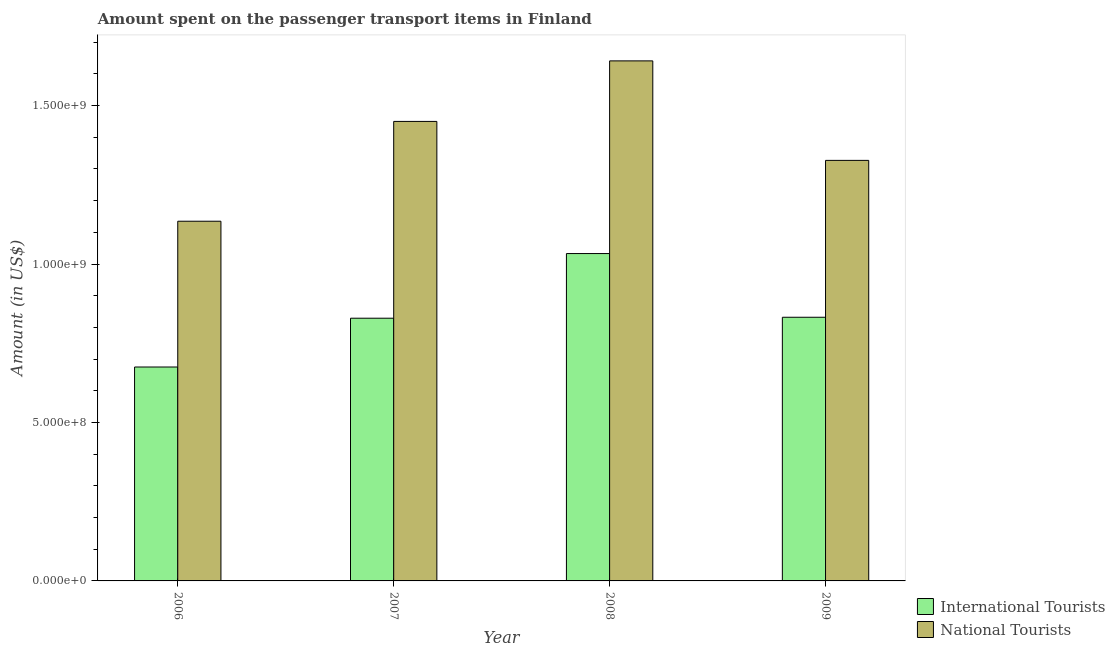How many different coloured bars are there?
Provide a short and direct response. 2. How many groups of bars are there?
Your response must be concise. 4. How many bars are there on the 4th tick from the left?
Offer a very short reply. 2. How many bars are there on the 4th tick from the right?
Provide a short and direct response. 2. In how many cases, is the number of bars for a given year not equal to the number of legend labels?
Give a very brief answer. 0. What is the amount spent on transport items of national tourists in 2008?
Offer a very short reply. 1.64e+09. Across all years, what is the maximum amount spent on transport items of national tourists?
Provide a short and direct response. 1.64e+09. Across all years, what is the minimum amount spent on transport items of international tourists?
Your response must be concise. 6.75e+08. In which year was the amount spent on transport items of national tourists maximum?
Offer a very short reply. 2008. In which year was the amount spent on transport items of national tourists minimum?
Provide a short and direct response. 2006. What is the total amount spent on transport items of national tourists in the graph?
Give a very brief answer. 5.55e+09. What is the difference between the amount spent on transport items of international tourists in 2006 and that in 2009?
Your response must be concise. -1.57e+08. What is the difference between the amount spent on transport items of national tourists in 2006 and the amount spent on transport items of international tourists in 2008?
Offer a terse response. -5.06e+08. What is the average amount spent on transport items of national tourists per year?
Offer a very short reply. 1.39e+09. In the year 2008, what is the difference between the amount spent on transport items of national tourists and amount spent on transport items of international tourists?
Ensure brevity in your answer.  0. In how many years, is the amount spent on transport items of national tourists greater than 1200000000 US$?
Provide a succinct answer. 3. What is the ratio of the amount spent on transport items of international tourists in 2008 to that in 2009?
Offer a very short reply. 1.24. Is the amount spent on transport items of international tourists in 2006 less than that in 2009?
Your response must be concise. Yes. Is the difference between the amount spent on transport items of international tourists in 2006 and 2009 greater than the difference between the amount spent on transport items of national tourists in 2006 and 2009?
Provide a succinct answer. No. What is the difference between the highest and the second highest amount spent on transport items of national tourists?
Your answer should be very brief. 1.91e+08. What is the difference between the highest and the lowest amount spent on transport items of national tourists?
Keep it short and to the point. 5.06e+08. In how many years, is the amount spent on transport items of international tourists greater than the average amount spent on transport items of international tourists taken over all years?
Provide a short and direct response. 1. Is the sum of the amount spent on transport items of international tourists in 2006 and 2007 greater than the maximum amount spent on transport items of national tourists across all years?
Ensure brevity in your answer.  Yes. What does the 2nd bar from the left in 2006 represents?
Offer a very short reply. National Tourists. What does the 2nd bar from the right in 2006 represents?
Your answer should be compact. International Tourists. How many years are there in the graph?
Your response must be concise. 4. Does the graph contain any zero values?
Make the answer very short. No. Does the graph contain grids?
Ensure brevity in your answer.  No. How many legend labels are there?
Your answer should be compact. 2. What is the title of the graph?
Give a very brief answer. Amount spent on the passenger transport items in Finland. What is the label or title of the X-axis?
Make the answer very short. Year. What is the Amount (in US$) of International Tourists in 2006?
Provide a short and direct response. 6.75e+08. What is the Amount (in US$) of National Tourists in 2006?
Your answer should be very brief. 1.14e+09. What is the Amount (in US$) of International Tourists in 2007?
Keep it short and to the point. 8.29e+08. What is the Amount (in US$) in National Tourists in 2007?
Keep it short and to the point. 1.45e+09. What is the Amount (in US$) in International Tourists in 2008?
Provide a succinct answer. 1.03e+09. What is the Amount (in US$) in National Tourists in 2008?
Your response must be concise. 1.64e+09. What is the Amount (in US$) in International Tourists in 2009?
Make the answer very short. 8.32e+08. What is the Amount (in US$) of National Tourists in 2009?
Your answer should be compact. 1.33e+09. Across all years, what is the maximum Amount (in US$) in International Tourists?
Your answer should be very brief. 1.03e+09. Across all years, what is the maximum Amount (in US$) of National Tourists?
Keep it short and to the point. 1.64e+09. Across all years, what is the minimum Amount (in US$) in International Tourists?
Offer a very short reply. 6.75e+08. Across all years, what is the minimum Amount (in US$) in National Tourists?
Provide a short and direct response. 1.14e+09. What is the total Amount (in US$) in International Tourists in the graph?
Give a very brief answer. 3.37e+09. What is the total Amount (in US$) in National Tourists in the graph?
Provide a succinct answer. 5.55e+09. What is the difference between the Amount (in US$) of International Tourists in 2006 and that in 2007?
Give a very brief answer. -1.54e+08. What is the difference between the Amount (in US$) in National Tourists in 2006 and that in 2007?
Ensure brevity in your answer.  -3.15e+08. What is the difference between the Amount (in US$) in International Tourists in 2006 and that in 2008?
Make the answer very short. -3.58e+08. What is the difference between the Amount (in US$) in National Tourists in 2006 and that in 2008?
Your response must be concise. -5.06e+08. What is the difference between the Amount (in US$) of International Tourists in 2006 and that in 2009?
Offer a terse response. -1.57e+08. What is the difference between the Amount (in US$) in National Tourists in 2006 and that in 2009?
Offer a terse response. -1.92e+08. What is the difference between the Amount (in US$) of International Tourists in 2007 and that in 2008?
Your answer should be very brief. -2.04e+08. What is the difference between the Amount (in US$) of National Tourists in 2007 and that in 2008?
Your answer should be compact. -1.91e+08. What is the difference between the Amount (in US$) of National Tourists in 2007 and that in 2009?
Offer a terse response. 1.23e+08. What is the difference between the Amount (in US$) of International Tourists in 2008 and that in 2009?
Ensure brevity in your answer.  2.01e+08. What is the difference between the Amount (in US$) in National Tourists in 2008 and that in 2009?
Make the answer very short. 3.14e+08. What is the difference between the Amount (in US$) in International Tourists in 2006 and the Amount (in US$) in National Tourists in 2007?
Ensure brevity in your answer.  -7.75e+08. What is the difference between the Amount (in US$) of International Tourists in 2006 and the Amount (in US$) of National Tourists in 2008?
Make the answer very short. -9.66e+08. What is the difference between the Amount (in US$) of International Tourists in 2006 and the Amount (in US$) of National Tourists in 2009?
Keep it short and to the point. -6.52e+08. What is the difference between the Amount (in US$) of International Tourists in 2007 and the Amount (in US$) of National Tourists in 2008?
Give a very brief answer. -8.12e+08. What is the difference between the Amount (in US$) in International Tourists in 2007 and the Amount (in US$) in National Tourists in 2009?
Your answer should be compact. -4.98e+08. What is the difference between the Amount (in US$) in International Tourists in 2008 and the Amount (in US$) in National Tourists in 2009?
Provide a short and direct response. -2.94e+08. What is the average Amount (in US$) in International Tourists per year?
Offer a very short reply. 8.42e+08. What is the average Amount (in US$) of National Tourists per year?
Your answer should be compact. 1.39e+09. In the year 2006, what is the difference between the Amount (in US$) of International Tourists and Amount (in US$) of National Tourists?
Provide a succinct answer. -4.60e+08. In the year 2007, what is the difference between the Amount (in US$) of International Tourists and Amount (in US$) of National Tourists?
Give a very brief answer. -6.21e+08. In the year 2008, what is the difference between the Amount (in US$) in International Tourists and Amount (in US$) in National Tourists?
Make the answer very short. -6.08e+08. In the year 2009, what is the difference between the Amount (in US$) of International Tourists and Amount (in US$) of National Tourists?
Keep it short and to the point. -4.95e+08. What is the ratio of the Amount (in US$) of International Tourists in 2006 to that in 2007?
Provide a short and direct response. 0.81. What is the ratio of the Amount (in US$) in National Tourists in 2006 to that in 2007?
Ensure brevity in your answer.  0.78. What is the ratio of the Amount (in US$) of International Tourists in 2006 to that in 2008?
Make the answer very short. 0.65. What is the ratio of the Amount (in US$) in National Tourists in 2006 to that in 2008?
Offer a terse response. 0.69. What is the ratio of the Amount (in US$) of International Tourists in 2006 to that in 2009?
Provide a succinct answer. 0.81. What is the ratio of the Amount (in US$) in National Tourists in 2006 to that in 2009?
Ensure brevity in your answer.  0.86. What is the ratio of the Amount (in US$) in International Tourists in 2007 to that in 2008?
Make the answer very short. 0.8. What is the ratio of the Amount (in US$) of National Tourists in 2007 to that in 2008?
Make the answer very short. 0.88. What is the ratio of the Amount (in US$) of International Tourists in 2007 to that in 2009?
Your response must be concise. 1. What is the ratio of the Amount (in US$) in National Tourists in 2007 to that in 2009?
Keep it short and to the point. 1.09. What is the ratio of the Amount (in US$) of International Tourists in 2008 to that in 2009?
Ensure brevity in your answer.  1.24. What is the ratio of the Amount (in US$) of National Tourists in 2008 to that in 2009?
Your answer should be compact. 1.24. What is the difference between the highest and the second highest Amount (in US$) in International Tourists?
Offer a terse response. 2.01e+08. What is the difference between the highest and the second highest Amount (in US$) in National Tourists?
Your answer should be very brief. 1.91e+08. What is the difference between the highest and the lowest Amount (in US$) of International Tourists?
Make the answer very short. 3.58e+08. What is the difference between the highest and the lowest Amount (in US$) of National Tourists?
Your answer should be compact. 5.06e+08. 